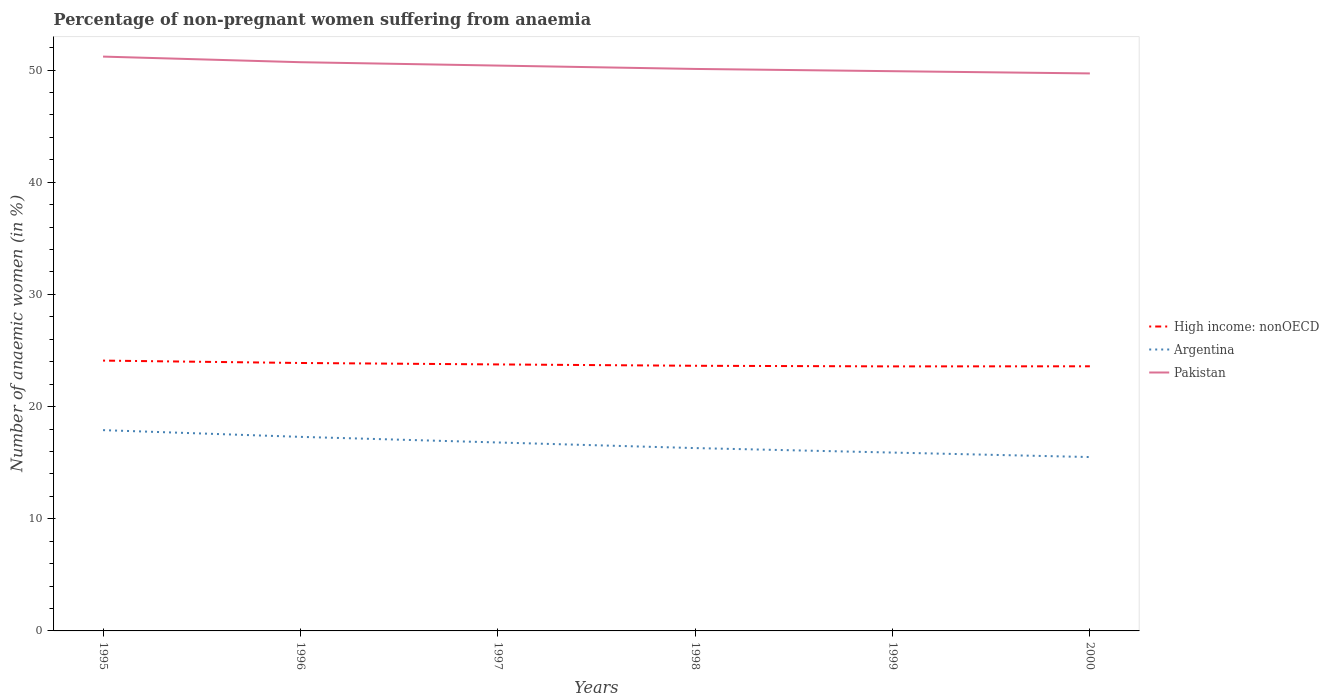Does the line corresponding to Argentina intersect with the line corresponding to Pakistan?
Your answer should be very brief. No. Is the number of lines equal to the number of legend labels?
Your response must be concise. Yes. Across all years, what is the maximum percentage of non-pregnant women suffering from anaemia in High income: nonOECD?
Keep it short and to the point. 23.58. What is the difference between the highest and the lowest percentage of non-pregnant women suffering from anaemia in Pakistan?
Your answer should be very brief. 3. Are the values on the major ticks of Y-axis written in scientific E-notation?
Offer a very short reply. No. Does the graph contain grids?
Give a very brief answer. No. How many legend labels are there?
Provide a short and direct response. 3. What is the title of the graph?
Provide a short and direct response. Percentage of non-pregnant women suffering from anaemia. Does "Hong Kong" appear as one of the legend labels in the graph?
Keep it short and to the point. No. What is the label or title of the X-axis?
Offer a terse response. Years. What is the label or title of the Y-axis?
Give a very brief answer. Number of anaemic women (in %). What is the Number of anaemic women (in %) in High income: nonOECD in 1995?
Provide a succinct answer. 24.1. What is the Number of anaemic women (in %) of Pakistan in 1995?
Offer a very short reply. 51.2. What is the Number of anaemic women (in %) of High income: nonOECD in 1996?
Provide a short and direct response. 23.89. What is the Number of anaemic women (in %) in Argentina in 1996?
Your answer should be compact. 17.3. What is the Number of anaemic women (in %) of Pakistan in 1996?
Offer a terse response. 50.7. What is the Number of anaemic women (in %) of High income: nonOECD in 1997?
Offer a very short reply. 23.76. What is the Number of anaemic women (in %) of Argentina in 1997?
Offer a very short reply. 16.8. What is the Number of anaemic women (in %) of Pakistan in 1997?
Offer a terse response. 50.4. What is the Number of anaemic women (in %) in High income: nonOECD in 1998?
Your answer should be compact. 23.64. What is the Number of anaemic women (in %) of Pakistan in 1998?
Your answer should be compact. 50.1. What is the Number of anaemic women (in %) in High income: nonOECD in 1999?
Give a very brief answer. 23.58. What is the Number of anaemic women (in %) of Pakistan in 1999?
Provide a succinct answer. 49.9. What is the Number of anaemic women (in %) of High income: nonOECD in 2000?
Your answer should be compact. 23.59. What is the Number of anaemic women (in %) in Pakistan in 2000?
Offer a very short reply. 49.7. Across all years, what is the maximum Number of anaemic women (in %) in High income: nonOECD?
Ensure brevity in your answer.  24.1. Across all years, what is the maximum Number of anaemic women (in %) of Pakistan?
Offer a terse response. 51.2. Across all years, what is the minimum Number of anaemic women (in %) in High income: nonOECD?
Offer a very short reply. 23.58. Across all years, what is the minimum Number of anaemic women (in %) of Pakistan?
Make the answer very short. 49.7. What is the total Number of anaemic women (in %) of High income: nonOECD in the graph?
Give a very brief answer. 142.55. What is the total Number of anaemic women (in %) of Argentina in the graph?
Give a very brief answer. 99.7. What is the total Number of anaemic women (in %) of Pakistan in the graph?
Your answer should be very brief. 302. What is the difference between the Number of anaemic women (in %) in High income: nonOECD in 1995 and that in 1996?
Your answer should be compact. 0.21. What is the difference between the Number of anaemic women (in %) of High income: nonOECD in 1995 and that in 1997?
Make the answer very short. 0.34. What is the difference between the Number of anaemic women (in %) of Argentina in 1995 and that in 1997?
Keep it short and to the point. 1.1. What is the difference between the Number of anaemic women (in %) of High income: nonOECD in 1995 and that in 1998?
Make the answer very short. 0.46. What is the difference between the Number of anaemic women (in %) of High income: nonOECD in 1995 and that in 1999?
Make the answer very short. 0.52. What is the difference between the Number of anaemic women (in %) in Argentina in 1995 and that in 1999?
Ensure brevity in your answer.  2. What is the difference between the Number of anaemic women (in %) in Pakistan in 1995 and that in 1999?
Make the answer very short. 1.3. What is the difference between the Number of anaemic women (in %) of High income: nonOECD in 1995 and that in 2000?
Provide a succinct answer. 0.51. What is the difference between the Number of anaemic women (in %) of Pakistan in 1995 and that in 2000?
Offer a very short reply. 1.5. What is the difference between the Number of anaemic women (in %) of High income: nonOECD in 1996 and that in 1997?
Your response must be concise. 0.13. What is the difference between the Number of anaemic women (in %) in Argentina in 1996 and that in 1997?
Give a very brief answer. 0.5. What is the difference between the Number of anaemic women (in %) of Pakistan in 1996 and that in 1997?
Your answer should be very brief. 0.3. What is the difference between the Number of anaemic women (in %) of High income: nonOECD in 1996 and that in 1998?
Ensure brevity in your answer.  0.25. What is the difference between the Number of anaemic women (in %) in Argentina in 1996 and that in 1998?
Make the answer very short. 1. What is the difference between the Number of anaemic women (in %) in High income: nonOECD in 1996 and that in 1999?
Ensure brevity in your answer.  0.3. What is the difference between the Number of anaemic women (in %) of Argentina in 1996 and that in 1999?
Your answer should be very brief. 1.4. What is the difference between the Number of anaemic women (in %) in Pakistan in 1996 and that in 1999?
Keep it short and to the point. 0.8. What is the difference between the Number of anaemic women (in %) of High income: nonOECD in 1996 and that in 2000?
Make the answer very short. 0.29. What is the difference between the Number of anaemic women (in %) of Argentina in 1996 and that in 2000?
Provide a short and direct response. 1.8. What is the difference between the Number of anaemic women (in %) of High income: nonOECD in 1997 and that in 1998?
Offer a terse response. 0.12. What is the difference between the Number of anaemic women (in %) of Argentina in 1997 and that in 1998?
Make the answer very short. 0.5. What is the difference between the Number of anaemic women (in %) in Pakistan in 1997 and that in 1998?
Offer a very short reply. 0.3. What is the difference between the Number of anaemic women (in %) of High income: nonOECD in 1997 and that in 1999?
Give a very brief answer. 0.17. What is the difference between the Number of anaemic women (in %) of Pakistan in 1997 and that in 1999?
Your answer should be very brief. 0.5. What is the difference between the Number of anaemic women (in %) of High income: nonOECD in 1997 and that in 2000?
Your response must be concise. 0.17. What is the difference between the Number of anaemic women (in %) in High income: nonOECD in 1998 and that in 1999?
Provide a short and direct response. 0.05. What is the difference between the Number of anaemic women (in %) of Argentina in 1998 and that in 1999?
Your answer should be compact. 0.4. What is the difference between the Number of anaemic women (in %) in Pakistan in 1998 and that in 1999?
Keep it short and to the point. 0.2. What is the difference between the Number of anaemic women (in %) of High income: nonOECD in 1998 and that in 2000?
Provide a succinct answer. 0.05. What is the difference between the Number of anaemic women (in %) in Argentina in 1998 and that in 2000?
Offer a terse response. 0.8. What is the difference between the Number of anaemic women (in %) of Pakistan in 1998 and that in 2000?
Keep it short and to the point. 0.4. What is the difference between the Number of anaemic women (in %) in High income: nonOECD in 1999 and that in 2000?
Give a very brief answer. -0.01. What is the difference between the Number of anaemic women (in %) in Argentina in 1999 and that in 2000?
Your answer should be very brief. 0.4. What is the difference between the Number of anaemic women (in %) in Pakistan in 1999 and that in 2000?
Offer a terse response. 0.2. What is the difference between the Number of anaemic women (in %) in High income: nonOECD in 1995 and the Number of anaemic women (in %) in Argentina in 1996?
Your answer should be very brief. 6.8. What is the difference between the Number of anaemic women (in %) of High income: nonOECD in 1995 and the Number of anaemic women (in %) of Pakistan in 1996?
Your answer should be very brief. -26.6. What is the difference between the Number of anaemic women (in %) in Argentina in 1995 and the Number of anaemic women (in %) in Pakistan in 1996?
Your answer should be very brief. -32.8. What is the difference between the Number of anaemic women (in %) of High income: nonOECD in 1995 and the Number of anaemic women (in %) of Argentina in 1997?
Provide a short and direct response. 7.3. What is the difference between the Number of anaemic women (in %) in High income: nonOECD in 1995 and the Number of anaemic women (in %) in Pakistan in 1997?
Your answer should be compact. -26.3. What is the difference between the Number of anaemic women (in %) in Argentina in 1995 and the Number of anaemic women (in %) in Pakistan in 1997?
Your answer should be very brief. -32.5. What is the difference between the Number of anaemic women (in %) of High income: nonOECD in 1995 and the Number of anaemic women (in %) of Argentina in 1998?
Offer a terse response. 7.8. What is the difference between the Number of anaemic women (in %) of High income: nonOECD in 1995 and the Number of anaemic women (in %) of Pakistan in 1998?
Your answer should be compact. -26. What is the difference between the Number of anaemic women (in %) of Argentina in 1995 and the Number of anaemic women (in %) of Pakistan in 1998?
Give a very brief answer. -32.2. What is the difference between the Number of anaemic women (in %) of High income: nonOECD in 1995 and the Number of anaemic women (in %) of Argentina in 1999?
Your response must be concise. 8.2. What is the difference between the Number of anaemic women (in %) in High income: nonOECD in 1995 and the Number of anaemic women (in %) in Pakistan in 1999?
Make the answer very short. -25.8. What is the difference between the Number of anaemic women (in %) in Argentina in 1995 and the Number of anaemic women (in %) in Pakistan in 1999?
Provide a succinct answer. -32. What is the difference between the Number of anaemic women (in %) of High income: nonOECD in 1995 and the Number of anaemic women (in %) of Argentina in 2000?
Your response must be concise. 8.6. What is the difference between the Number of anaemic women (in %) of High income: nonOECD in 1995 and the Number of anaemic women (in %) of Pakistan in 2000?
Provide a short and direct response. -25.6. What is the difference between the Number of anaemic women (in %) in Argentina in 1995 and the Number of anaemic women (in %) in Pakistan in 2000?
Your response must be concise. -31.8. What is the difference between the Number of anaemic women (in %) of High income: nonOECD in 1996 and the Number of anaemic women (in %) of Argentina in 1997?
Ensure brevity in your answer.  7.09. What is the difference between the Number of anaemic women (in %) of High income: nonOECD in 1996 and the Number of anaemic women (in %) of Pakistan in 1997?
Provide a short and direct response. -26.51. What is the difference between the Number of anaemic women (in %) of Argentina in 1996 and the Number of anaemic women (in %) of Pakistan in 1997?
Your answer should be very brief. -33.1. What is the difference between the Number of anaemic women (in %) of High income: nonOECD in 1996 and the Number of anaemic women (in %) of Argentina in 1998?
Your answer should be compact. 7.59. What is the difference between the Number of anaemic women (in %) of High income: nonOECD in 1996 and the Number of anaemic women (in %) of Pakistan in 1998?
Provide a succinct answer. -26.21. What is the difference between the Number of anaemic women (in %) of Argentina in 1996 and the Number of anaemic women (in %) of Pakistan in 1998?
Provide a succinct answer. -32.8. What is the difference between the Number of anaemic women (in %) in High income: nonOECD in 1996 and the Number of anaemic women (in %) in Argentina in 1999?
Offer a terse response. 7.99. What is the difference between the Number of anaemic women (in %) in High income: nonOECD in 1996 and the Number of anaemic women (in %) in Pakistan in 1999?
Provide a short and direct response. -26.01. What is the difference between the Number of anaemic women (in %) of Argentina in 1996 and the Number of anaemic women (in %) of Pakistan in 1999?
Keep it short and to the point. -32.6. What is the difference between the Number of anaemic women (in %) in High income: nonOECD in 1996 and the Number of anaemic women (in %) in Argentina in 2000?
Your answer should be compact. 8.39. What is the difference between the Number of anaemic women (in %) in High income: nonOECD in 1996 and the Number of anaemic women (in %) in Pakistan in 2000?
Provide a short and direct response. -25.81. What is the difference between the Number of anaemic women (in %) in Argentina in 1996 and the Number of anaemic women (in %) in Pakistan in 2000?
Keep it short and to the point. -32.4. What is the difference between the Number of anaemic women (in %) of High income: nonOECD in 1997 and the Number of anaemic women (in %) of Argentina in 1998?
Make the answer very short. 7.46. What is the difference between the Number of anaemic women (in %) in High income: nonOECD in 1997 and the Number of anaemic women (in %) in Pakistan in 1998?
Keep it short and to the point. -26.34. What is the difference between the Number of anaemic women (in %) of Argentina in 1997 and the Number of anaemic women (in %) of Pakistan in 1998?
Provide a short and direct response. -33.3. What is the difference between the Number of anaemic women (in %) in High income: nonOECD in 1997 and the Number of anaemic women (in %) in Argentina in 1999?
Offer a terse response. 7.86. What is the difference between the Number of anaemic women (in %) of High income: nonOECD in 1997 and the Number of anaemic women (in %) of Pakistan in 1999?
Your response must be concise. -26.14. What is the difference between the Number of anaemic women (in %) in Argentina in 1997 and the Number of anaemic women (in %) in Pakistan in 1999?
Your answer should be compact. -33.1. What is the difference between the Number of anaemic women (in %) in High income: nonOECD in 1997 and the Number of anaemic women (in %) in Argentina in 2000?
Your response must be concise. 8.26. What is the difference between the Number of anaemic women (in %) in High income: nonOECD in 1997 and the Number of anaemic women (in %) in Pakistan in 2000?
Ensure brevity in your answer.  -25.94. What is the difference between the Number of anaemic women (in %) in Argentina in 1997 and the Number of anaemic women (in %) in Pakistan in 2000?
Your answer should be compact. -32.9. What is the difference between the Number of anaemic women (in %) in High income: nonOECD in 1998 and the Number of anaemic women (in %) in Argentina in 1999?
Offer a very short reply. 7.74. What is the difference between the Number of anaemic women (in %) of High income: nonOECD in 1998 and the Number of anaemic women (in %) of Pakistan in 1999?
Your response must be concise. -26.26. What is the difference between the Number of anaemic women (in %) in Argentina in 1998 and the Number of anaemic women (in %) in Pakistan in 1999?
Ensure brevity in your answer.  -33.6. What is the difference between the Number of anaemic women (in %) in High income: nonOECD in 1998 and the Number of anaemic women (in %) in Argentina in 2000?
Your response must be concise. 8.14. What is the difference between the Number of anaemic women (in %) of High income: nonOECD in 1998 and the Number of anaemic women (in %) of Pakistan in 2000?
Your answer should be compact. -26.06. What is the difference between the Number of anaemic women (in %) in Argentina in 1998 and the Number of anaemic women (in %) in Pakistan in 2000?
Provide a succinct answer. -33.4. What is the difference between the Number of anaemic women (in %) in High income: nonOECD in 1999 and the Number of anaemic women (in %) in Argentina in 2000?
Your response must be concise. 8.08. What is the difference between the Number of anaemic women (in %) of High income: nonOECD in 1999 and the Number of anaemic women (in %) of Pakistan in 2000?
Keep it short and to the point. -26.12. What is the difference between the Number of anaemic women (in %) of Argentina in 1999 and the Number of anaemic women (in %) of Pakistan in 2000?
Ensure brevity in your answer.  -33.8. What is the average Number of anaemic women (in %) in High income: nonOECD per year?
Make the answer very short. 23.76. What is the average Number of anaemic women (in %) of Argentina per year?
Offer a terse response. 16.62. What is the average Number of anaemic women (in %) in Pakistan per year?
Keep it short and to the point. 50.33. In the year 1995, what is the difference between the Number of anaemic women (in %) of High income: nonOECD and Number of anaemic women (in %) of Argentina?
Your answer should be compact. 6.2. In the year 1995, what is the difference between the Number of anaemic women (in %) of High income: nonOECD and Number of anaemic women (in %) of Pakistan?
Offer a very short reply. -27.1. In the year 1995, what is the difference between the Number of anaemic women (in %) of Argentina and Number of anaemic women (in %) of Pakistan?
Your answer should be compact. -33.3. In the year 1996, what is the difference between the Number of anaemic women (in %) in High income: nonOECD and Number of anaemic women (in %) in Argentina?
Your answer should be very brief. 6.59. In the year 1996, what is the difference between the Number of anaemic women (in %) of High income: nonOECD and Number of anaemic women (in %) of Pakistan?
Make the answer very short. -26.81. In the year 1996, what is the difference between the Number of anaemic women (in %) in Argentina and Number of anaemic women (in %) in Pakistan?
Your response must be concise. -33.4. In the year 1997, what is the difference between the Number of anaemic women (in %) of High income: nonOECD and Number of anaemic women (in %) of Argentina?
Your answer should be very brief. 6.96. In the year 1997, what is the difference between the Number of anaemic women (in %) in High income: nonOECD and Number of anaemic women (in %) in Pakistan?
Offer a terse response. -26.64. In the year 1997, what is the difference between the Number of anaemic women (in %) in Argentina and Number of anaemic women (in %) in Pakistan?
Your response must be concise. -33.6. In the year 1998, what is the difference between the Number of anaemic women (in %) in High income: nonOECD and Number of anaemic women (in %) in Argentina?
Give a very brief answer. 7.34. In the year 1998, what is the difference between the Number of anaemic women (in %) in High income: nonOECD and Number of anaemic women (in %) in Pakistan?
Your answer should be compact. -26.46. In the year 1998, what is the difference between the Number of anaemic women (in %) in Argentina and Number of anaemic women (in %) in Pakistan?
Your response must be concise. -33.8. In the year 1999, what is the difference between the Number of anaemic women (in %) of High income: nonOECD and Number of anaemic women (in %) of Argentina?
Make the answer very short. 7.68. In the year 1999, what is the difference between the Number of anaemic women (in %) in High income: nonOECD and Number of anaemic women (in %) in Pakistan?
Your response must be concise. -26.32. In the year 1999, what is the difference between the Number of anaemic women (in %) of Argentina and Number of anaemic women (in %) of Pakistan?
Give a very brief answer. -34. In the year 2000, what is the difference between the Number of anaemic women (in %) in High income: nonOECD and Number of anaemic women (in %) in Argentina?
Ensure brevity in your answer.  8.09. In the year 2000, what is the difference between the Number of anaemic women (in %) of High income: nonOECD and Number of anaemic women (in %) of Pakistan?
Your answer should be very brief. -26.11. In the year 2000, what is the difference between the Number of anaemic women (in %) in Argentina and Number of anaemic women (in %) in Pakistan?
Give a very brief answer. -34.2. What is the ratio of the Number of anaemic women (in %) of High income: nonOECD in 1995 to that in 1996?
Your answer should be compact. 1.01. What is the ratio of the Number of anaemic women (in %) in Argentina in 1995 to that in 1996?
Ensure brevity in your answer.  1.03. What is the ratio of the Number of anaemic women (in %) of Pakistan in 1995 to that in 1996?
Provide a short and direct response. 1.01. What is the ratio of the Number of anaemic women (in %) of High income: nonOECD in 1995 to that in 1997?
Your answer should be very brief. 1.01. What is the ratio of the Number of anaemic women (in %) in Argentina in 1995 to that in 1997?
Keep it short and to the point. 1.07. What is the ratio of the Number of anaemic women (in %) in Pakistan in 1995 to that in 1997?
Make the answer very short. 1.02. What is the ratio of the Number of anaemic women (in %) in High income: nonOECD in 1995 to that in 1998?
Offer a very short reply. 1.02. What is the ratio of the Number of anaemic women (in %) in Argentina in 1995 to that in 1998?
Provide a short and direct response. 1.1. What is the ratio of the Number of anaemic women (in %) in Pakistan in 1995 to that in 1998?
Provide a short and direct response. 1.02. What is the ratio of the Number of anaemic women (in %) in High income: nonOECD in 1995 to that in 1999?
Make the answer very short. 1.02. What is the ratio of the Number of anaemic women (in %) of Argentina in 1995 to that in 1999?
Your answer should be compact. 1.13. What is the ratio of the Number of anaemic women (in %) in Pakistan in 1995 to that in 1999?
Offer a terse response. 1.03. What is the ratio of the Number of anaemic women (in %) of High income: nonOECD in 1995 to that in 2000?
Offer a terse response. 1.02. What is the ratio of the Number of anaemic women (in %) in Argentina in 1995 to that in 2000?
Provide a short and direct response. 1.15. What is the ratio of the Number of anaemic women (in %) of Pakistan in 1995 to that in 2000?
Your answer should be very brief. 1.03. What is the ratio of the Number of anaemic women (in %) of High income: nonOECD in 1996 to that in 1997?
Give a very brief answer. 1.01. What is the ratio of the Number of anaemic women (in %) of Argentina in 1996 to that in 1997?
Ensure brevity in your answer.  1.03. What is the ratio of the Number of anaemic women (in %) of Pakistan in 1996 to that in 1997?
Give a very brief answer. 1.01. What is the ratio of the Number of anaemic women (in %) in High income: nonOECD in 1996 to that in 1998?
Give a very brief answer. 1.01. What is the ratio of the Number of anaemic women (in %) in Argentina in 1996 to that in 1998?
Make the answer very short. 1.06. What is the ratio of the Number of anaemic women (in %) in Pakistan in 1996 to that in 1998?
Your answer should be very brief. 1.01. What is the ratio of the Number of anaemic women (in %) in High income: nonOECD in 1996 to that in 1999?
Your answer should be very brief. 1.01. What is the ratio of the Number of anaemic women (in %) in Argentina in 1996 to that in 1999?
Your answer should be very brief. 1.09. What is the ratio of the Number of anaemic women (in %) of Pakistan in 1996 to that in 1999?
Your response must be concise. 1.02. What is the ratio of the Number of anaemic women (in %) in High income: nonOECD in 1996 to that in 2000?
Make the answer very short. 1.01. What is the ratio of the Number of anaemic women (in %) in Argentina in 1996 to that in 2000?
Keep it short and to the point. 1.12. What is the ratio of the Number of anaemic women (in %) in Pakistan in 1996 to that in 2000?
Offer a terse response. 1.02. What is the ratio of the Number of anaemic women (in %) of Argentina in 1997 to that in 1998?
Offer a very short reply. 1.03. What is the ratio of the Number of anaemic women (in %) in High income: nonOECD in 1997 to that in 1999?
Keep it short and to the point. 1.01. What is the ratio of the Number of anaemic women (in %) in Argentina in 1997 to that in 1999?
Provide a succinct answer. 1.06. What is the ratio of the Number of anaemic women (in %) in Pakistan in 1997 to that in 1999?
Your answer should be compact. 1.01. What is the ratio of the Number of anaemic women (in %) of High income: nonOECD in 1997 to that in 2000?
Keep it short and to the point. 1.01. What is the ratio of the Number of anaemic women (in %) in Argentina in 1997 to that in 2000?
Offer a terse response. 1.08. What is the ratio of the Number of anaemic women (in %) of Pakistan in 1997 to that in 2000?
Your response must be concise. 1.01. What is the ratio of the Number of anaemic women (in %) of Argentina in 1998 to that in 1999?
Your answer should be very brief. 1.03. What is the ratio of the Number of anaemic women (in %) of Argentina in 1998 to that in 2000?
Your answer should be compact. 1.05. What is the ratio of the Number of anaemic women (in %) in Argentina in 1999 to that in 2000?
Give a very brief answer. 1.03. What is the ratio of the Number of anaemic women (in %) of Pakistan in 1999 to that in 2000?
Offer a very short reply. 1. What is the difference between the highest and the second highest Number of anaemic women (in %) of High income: nonOECD?
Your answer should be compact. 0.21. What is the difference between the highest and the lowest Number of anaemic women (in %) in High income: nonOECD?
Offer a terse response. 0.52. What is the difference between the highest and the lowest Number of anaemic women (in %) of Pakistan?
Provide a succinct answer. 1.5. 